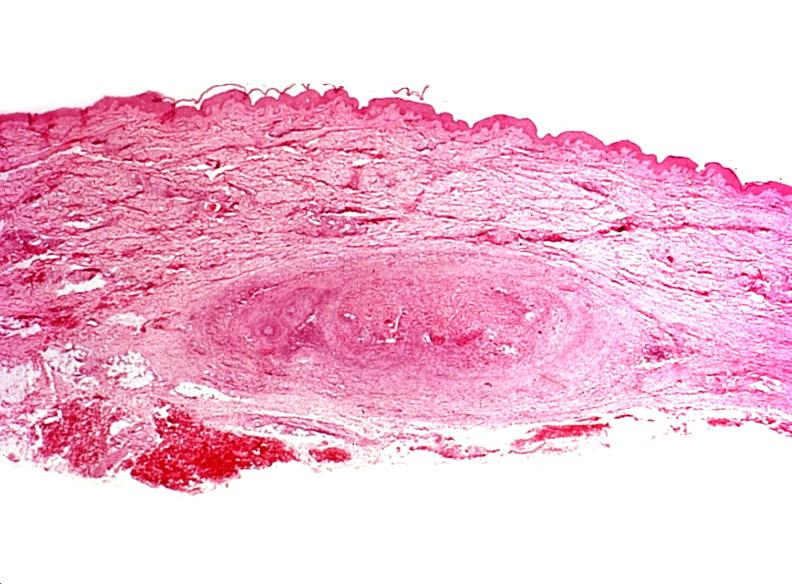does chromoblastomycosis show migratory thrombophlebitis?
Answer the question using a single word or phrase. No 